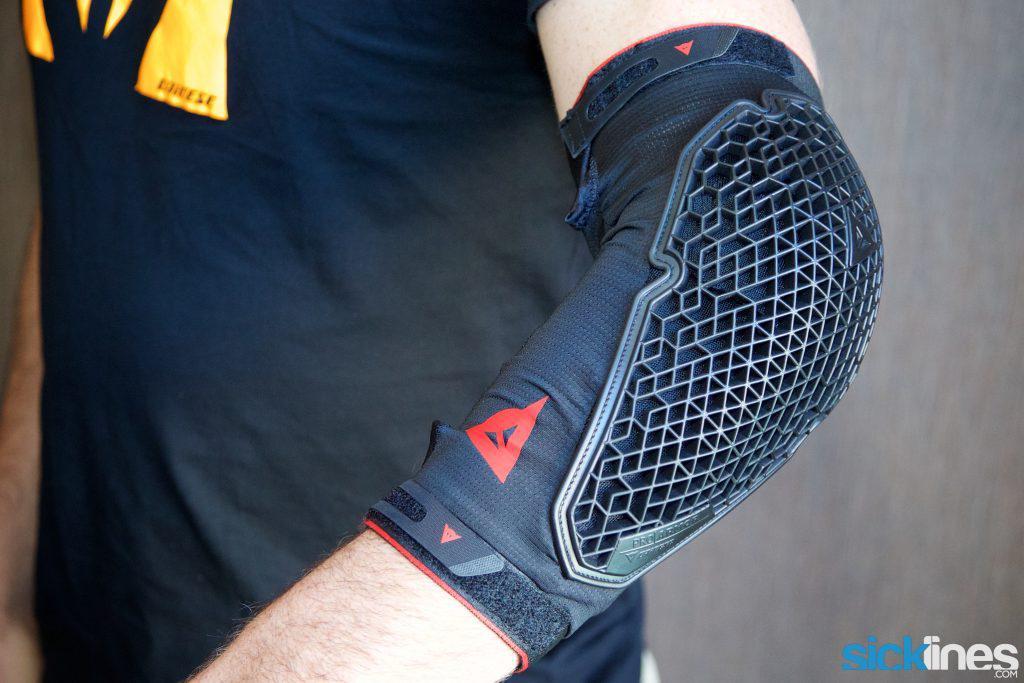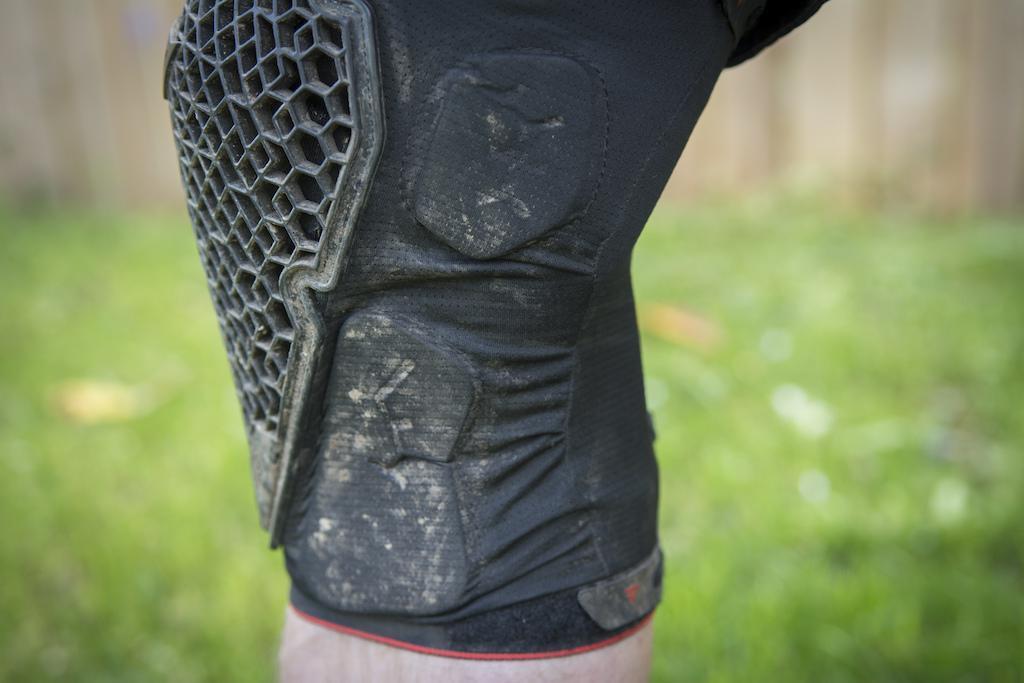The first image is the image on the left, the second image is the image on the right. Examine the images to the left and right. Is the description "In one image, a person is wearing a pair of knee pads with shorts, while the second image is one knee pad displayed on a model leg." accurate? Answer yes or no. No. The first image is the image on the left, the second image is the image on the right. For the images displayed, is the sentence "A person is wearing two knee braces in the image on the left." factually correct? Answer yes or no. No. 